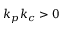<formula> <loc_0><loc_0><loc_500><loc_500>k _ { p } k _ { c } > 0</formula> 